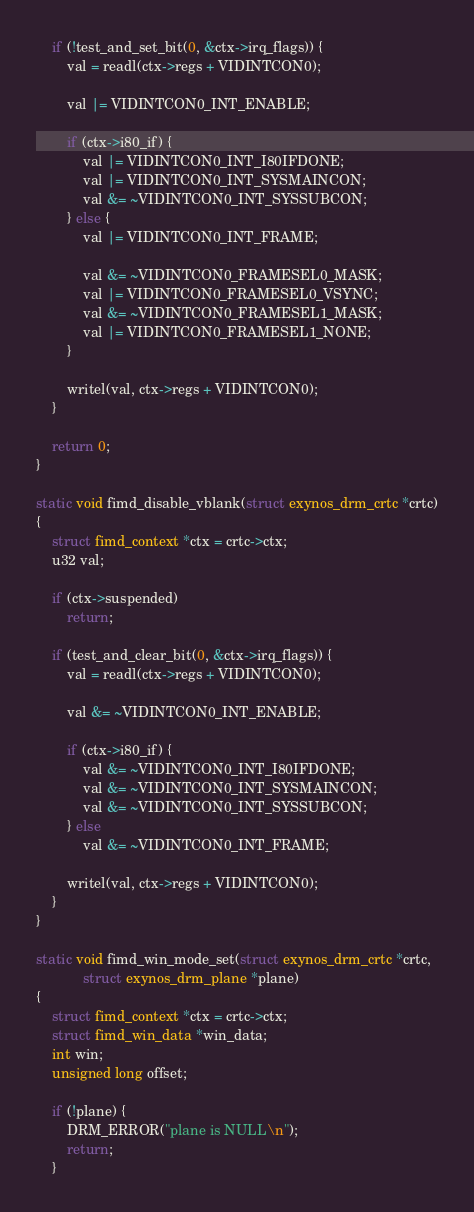Convert code to text. <code><loc_0><loc_0><loc_500><loc_500><_C_>
	if (!test_and_set_bit(0, &ctx->irq_flags)) {
		val = readl(ctx->regs + VIDINTCON0);

		val |= VIDINTCON0_INT_ENABLE;

		if (ctx->i80_if) {
			val |= VIDINTCON0_INT_I80IFDONE;
			val |= VIDINTCON0_INT_SYSMAINCON;
			val &= ~VIDINTCON0_INT_SYSSUBCON;
		} else {
			val |= VIDINTCON0_INT_FRAME;

			val &= ~VIDINTCON0_FRAMESEL0_MASK;
			val |= VIDINTCON0_FRAMESEL0_VSYNC;
			val &= ~VIDINTCON0_FRAMESEL1_MASK;
			val |= VIDINTCON0_FRAMESEL1_NONE;
		}

		writel(val, ctx->regs + VIDINTCON0);
	}

	return 0;
}

static void fimd_disable_vblank(struct exynos_drm_crtc *crtc)
{
	struct fimd_context *ctx = crtc->ctx;
	u32 val;

	if (ctx->suspended)
		return;

	if (test_and_clear_bit(0, &ctx->irq_flags)) {
		val = readl(ctx->regs + VIDINTCON0);

		val &= ~VIDINTCON0_INT_ENABLE;

		if (ctx->i80_if) {
			val &= ~VIDINTCON0_INT_I80IFDONE;
			val &= ~VIDINTCON0_INT_SYSMAINCON;
			val &= ~VIDINTCON0_INT_SYSSUBCON;
		} else
			val &= ~VIDINTCON0_INT_FRAME;

		writel(val, ctx->regs + VIDINTCON0);
	}
}

static void fimd_win_mode_set(struct exynos_drm_crtc *crtc,
			struct exynos_drm_plane *plane)
{
	struct fimd_context *ctx = crtc->ctx;
	struct fimd_win_data *win_data;
	int win;
	unsigned long offset;

	if (!plane) {
		DRM_ERROR("plane is NULL\n");
		return;
	}
</code> 